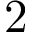Convert formula to latex. <formula><loc_0><loc_0><loc_500><loc_500>2 \ t i m e 2</formula> 